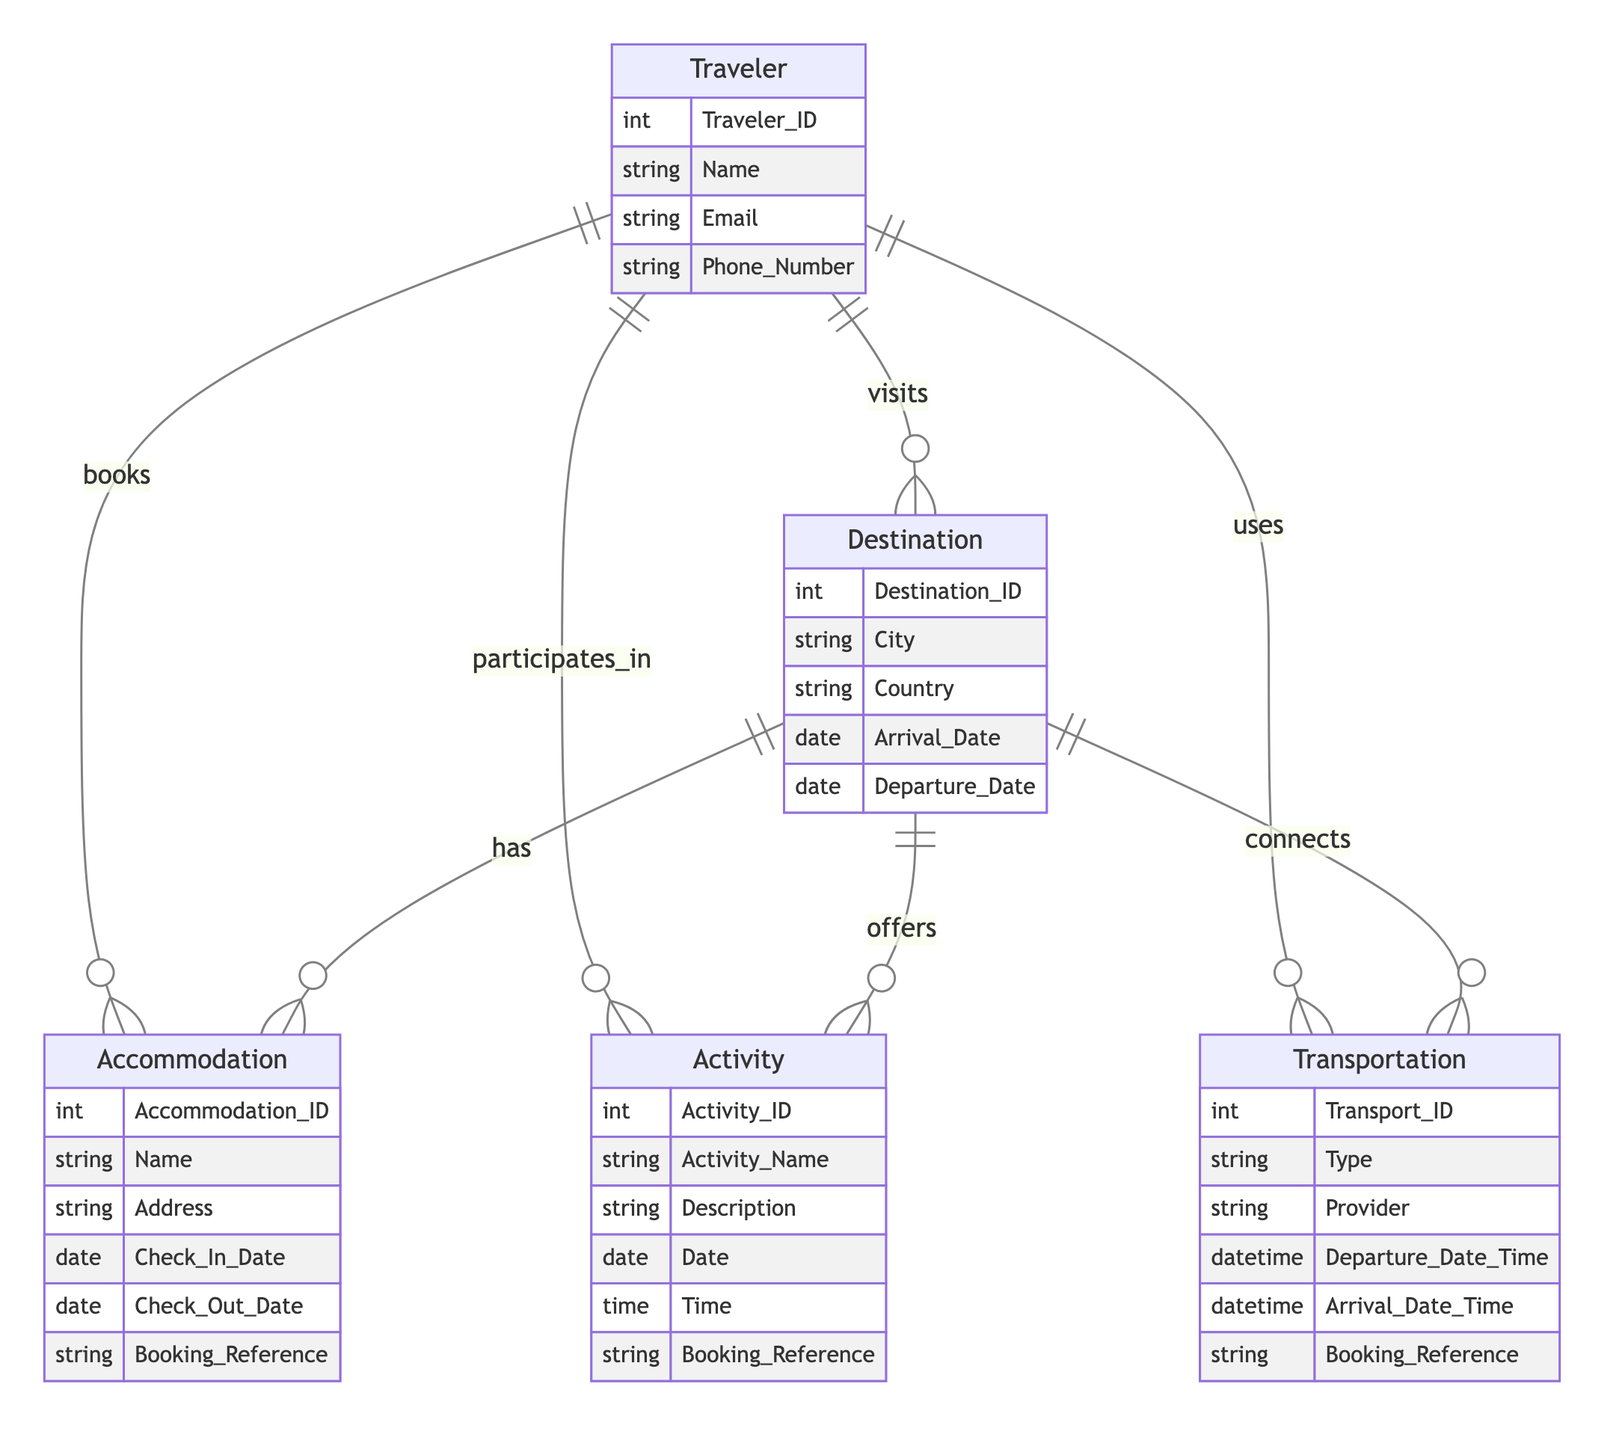What is the primary entity representing the individual traveling? The diagram identifies "Traveler" as the primary entity related to the individual engaged in travel activities. It is the starting point for relationships with destinations, accommodations, activities, and transportation.
Answer: Traveler How many relationships does the "Traveler" entity have? Counting the relationships from the "Traveler" entity, there are four distinct relationships with "Destination," "Accommodation," "Activity," and "Transportation."
Answer: 4 What attribute represents the unique identifier for accommodations? In the diagram, "Accommodation_ID" serves as the unique identifier for each accommodation, distinguishing them in the database.
Answer: Accommodation_ID Which entity connects "Destination" to "Transportation"? The relationship between "Destination" and "Transportation" is captured through the "Destination_Transportation" relationship, indicating that destinations can connect to forms of transportation.
Answer: Destination_Transportation What attribute would you find in the "Activity" entity related to bookings? The "Activity" entity includes the "Booking_Reference" attribute, which signifies the link to a specific booking associated with the activity.
Answer: Booking_Reference How many activities can a single traveler participate in according to the diagram? Given the relationship "Traveler_Acitivity," a single traveler can take part in multiple activities, as indicated by the one-to-many relationship shown in the ER diagram.
Answer: Multiple What is the purpose of the "Destination" entity? The role of the "Destination" entity is to represent various places that travelers visit, which include attributes like city, country, arrival date, and departure date.
Answer: Representing places How is "Accommodation" linked to "Destination"? The "Destination_Accommodation" relationship illustrates that accommodations are associated with specific destinations, showing that every accommodation resides in a particular destination.
Answer: Destination_Accommodation In what context can "Traveler" interact with "Activity"? The "Traveler_Acivity" relationship indicates that travelers can participate in various activities, establishing a connection between the traveler and the activities they engage in during their trips.
Answer: Participate in activities 